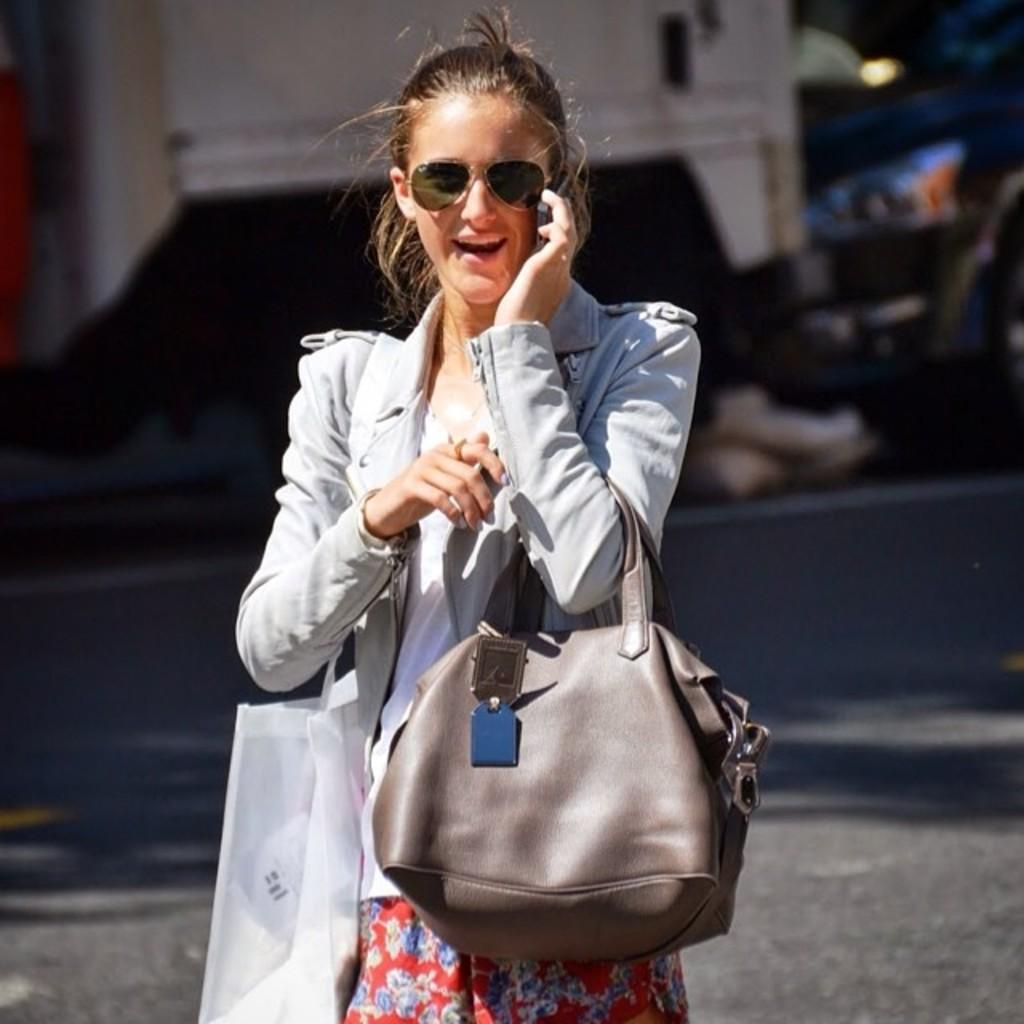Who is the main subject in the image? There is a woman in the image. What is the woman holding in her hands? The woman is holding a handbag and a cover. What is the woman doing with her mobile phone? The woman is talking on a mobile phone. What type of line is visible in the image? There is no line visible in the image. Is the queen present in the image? There is no queen present in the image. 